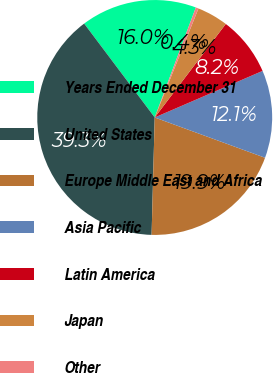Convert chart to OTSL. <chart><loc_0><loc_0><loc_500><loc_500><pie_chart><fcel>Years Ended December 31<fcel>United States<fcel>Europe Middle East and Africa<fcel>Asia Pacific<fcel>Latin America<fcel>Japan<fcel>Other<nl><fcel>15.95%<fcel>39.32%<fcel>19.85%<fcel>12.06%<fcel>8.17%<fcel>4.27%<fcel>0.38%<nl></chart> 